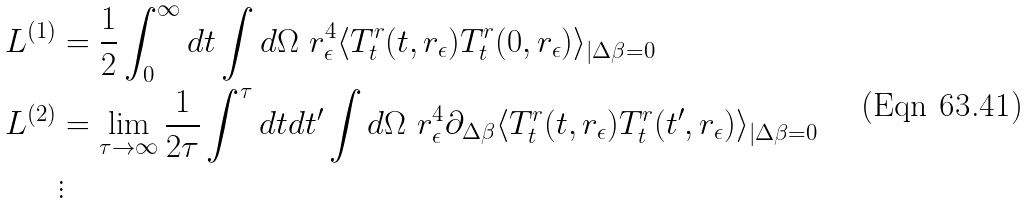<formula> <loc_0><loc_0><loc_500><loc_500>L ^ { ( 1 ) } & = \frac { 1 } { 2 } \int _ { 0 } ^ { \infty } d t \int d \Omega \ r _ { \epsilon } ^ { 4 } \langle T ^ { r } _ { t } ( t , r _ { \epsilon } ) T ^ { r } _ { t } ( 0 , r _ { \epsilon } ) \rangle _ { | \Delta \beta = 0 } \\ L ^ { ( 2 ) } & = \lim _ { \tau \to \infty } \frac { 1 } { 2 \tau } \int ^ { \tau } d t d t ^ { \prime } \int d \Omega \ r _ { \epsilon } ^ { 4 } \partial _ { \Delta \beta } \langle T ^ { r } _ { t } ( t , r _ { \epsilon } ) T ^ { r } _ { t } ( t ^ { \prime } , r _ { \epsilon } ) \rangle _ { | \Delta \beta = 0 } \\ & \vdots</formula> 